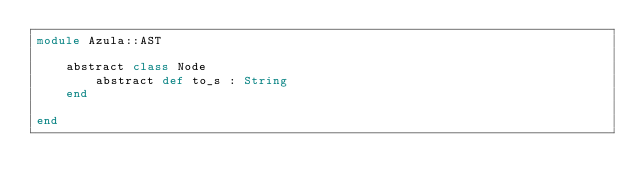<code> <loc_0><loc_0><loc_500><loc_500><_Crystal_>module Azula::AST

    abstract class Node
        abstract def to_s : String
    end

end</code> 